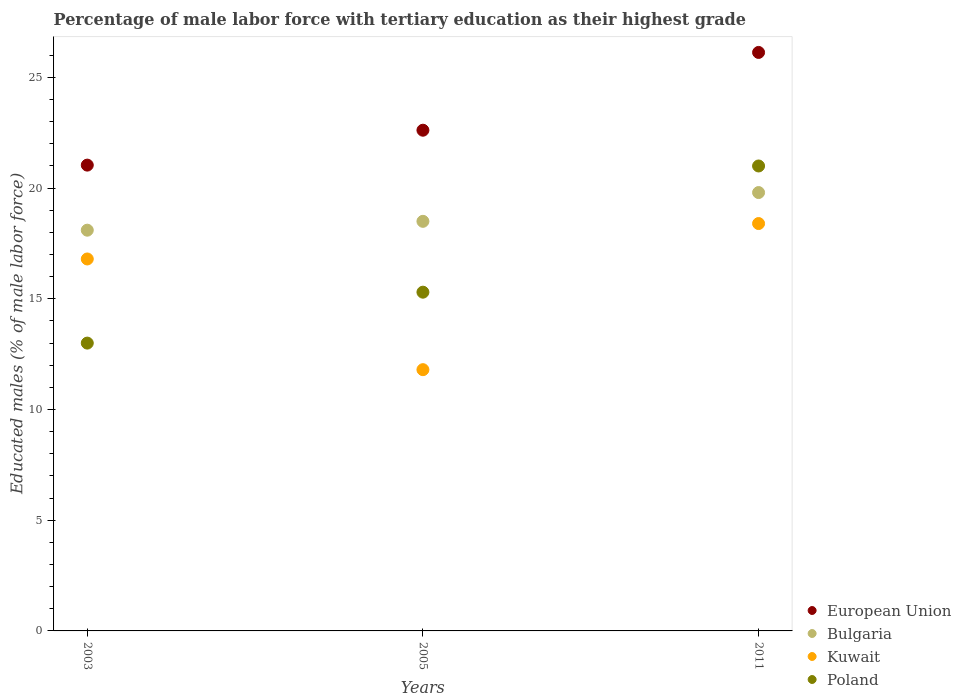Is the number of dotlines equal to the number of legend labels?
Provide a short and direct response. Yes. What is the percentage of male labor force with tertiary education in Poland in 2011?
Offer a very short reply. 21. Across all years, what is the maximum percentage of male labor force with tertiary education in Kuwait?
Offer a very short reply. 18.4. Across all years, what is the minimum percentage of male labor force with tertiary education in Bulgaria?
Your answer should be very brief. 18.1. What is the total percentage of male labor force with tertiary education in European Union in the graph?
Offer a very short reply. 69.78. What is the difference between the percentage of male labor force with tertiary education in Kuwait in 2003 and that in 2005?
Provide a short and direct response. 5. What is the difference between the percentage of male labor force with tertiary education in European Union in 2003 and the percentage of male labor force with tertiary education in Bulgaria in 2005?
Your answer should be very brief. 2.54. What is the average percentage of male labor force with tertiary education in European Union per year?
Give a very brief answer. 23.26. In the year 2003, what is the difference between the percentage of male labor force with tertiary education in European Union and percentage of male labor force with tertiary education in Poland?
Offer a very short reply. 8.04. In how many years, is the percentage of male labor force with tertiary education in European Union greater than 21 %?
Keep it short and to the point. 3. What is the ratio of the percentage of male labor force with tertiary education in Poland in 2003 to that in 2005?
Keep it short and to the point. 0.85. What is the difference between the highest and the second highest percentage of male labor force with tertiary education in European Union?
Make the answer very short. 3.51. What is the difference between the highest and the lowest percentage of male labor force with tertiary education in Bulgaria?
Your response must be concise. 1.7. Is it the case that in every year, the sum of the percentage of male labor force with tertiary education in Bulgaria and percentage of male labor force with tertiary education in Poland  is greater than the sum of percentage of male labor force with tertiary education in Kuwait and percentage of male labor force with tertiary education in European Union?
Make the answer very short. No. Is it the case that in every year, the sum of the percentage of male labor force with tertiary education in European Union and percentage of male labor force with tertiary education in Poland  is greater than the percentage of male labor force with tertiary education in Bulgaria?
Offer a terse response. Yes. Is the percentage of male labor force with tertiary education in Poland strictly greater than the percentage of male labor force with tertiary education in European Union over the years?
Provide a succinct answer. No. Is the percentage of male labor force with tertiary education in Kuwait strictly less than the percentage of male labor force with tertiary education in Poland over the years?
Make the answer very short. No. How many dotlines are there?
Your answer should be compact. 4. How many years are there in the graph?
Keep it short and to the point. 3. Does the graph contain any zero values?
Ensure brevity in your answer.  No. Does the graph contain grids?
Ensure brevity in your answer.  No. Where does the legend appear in the graph?
Ensure brevity in your answer.  Bottom right. How many legend labels are there?
Your answer should be compact. 4. How are the legend labels stacked?
Provide a succinct answer. Vertical. What is the title of the graph?
Your answer should be very brief. Percentage of male labor force with tertiary education as their highest grade. Does "Dominican Republic" appear as one of the legend labels in the graph?
Your answer should be compact. No. What is the label or title of the Y-axis?
Provide a short and direct response. Educated males (% of male labor force). What is the Educated males (% of male labor force) in European Union in 2003?
Provide a short and direct response. 21.04. What is the Educated males (% of male labor force) in Bulgaria in 2003?
Your answer should be compact. 18.1. What is the Educated males (% of male labor force) in Kuwait in 2003?
Your response must be concise. 16.8. What is the Educated males (% of male labor force) of European Union in 2005?
Provide a short and direct response. 22.62. What is the Educated males (% of male labor force) in Bulgaria in 2005?
Your answer should be compact. 18.5. What is the Educated males (% of male labor force) in Kuwait in 2005?
Ensure brevity in your answer.  11.8. What is the Educated males (% of male labor force) in Poland in 2005?
Your response must be concise. 15.3. What is the Educated males (% of male labor force) in European Union in 2011?
Ensure brevity in your answer.  26.13. What is the Educated males (% of male labor force) of Bulgaria in 2011?
Provide a succinct answer. 19.8. What is the Educated males (% of male labor force) in Kuwait in 2011?
Keep it short and to the point. 18.4. Across all years, what is the maximum Educated males (% of male labor force) of European Union?
Give a very brief answer. 26.13. Across all years, what is the maximum Educated males (% of male labor force) in Bulgaria?
Ensure brevity in your answer.  19.8. Across all years, what is the maximum Educated males (% of male labor force) in Kuwait?
Give a very brief answer. 18.4. Across all years, what is the minimum Educated males (% of male labor force) in European Union?
Keep it short and to the point. 21.04. Across all years, what is the minimum Educated males (% of male labor force) in Bulgaria?
Give a very brief answer. 18.1. Across all years, what is the minimum Educated males (% of male labor force) in Kuwait?
Keep it short and to the point. 11.8. Across all years, what is the minimum Educated males (% of male labor force) of Poland?
Provide a short and direct response. 13. What is the total Educated males (% of male labor force) in European Union in the graph?
Offer a very short reply. 69.78. What is the total Educated males (% of male labor force) in Bulgaria in the graph?
Keep it short and to the point. 56.4. What is the total Educated males (% of male labor force) of Poland in the graph?
Ensure brevity in your answer.  49.3. What is the difference between the Educated males (% of male labor force) of European Union in 2003 and that in 2005?
Provide a succinct answer. -1.58. What is the difference between the Educated males (% of male labor force) of Bulgaria in 2003 and that in 2005?
Your answer should be very brief. -0.4. What is the difference between the Educated males (% of male labor force) in Kuwait in 2003 and that in 2005?
Your answer should be very brief. 5. What is the difference between the Educated males (% of male labor force) in Poland in 2003 and that in 2005?
Ensure brevity in your answer.  -2.3. What is the difference between the Educated males (% of male labor force) of European Union in 2003 and that in 2011?
Offer a very short reply. -5.09. What is the difference between the Educated males (% of male labor force) in Bulgaria in 2003 and that in 2011?
Keep it short and to the point. -1.7. What is the difference between the Educated males (% of male labor force) in Kuwait in 2003 and that in 2011?
Your answer should be compact. -1.6. What is the difference between the Educated males (% of male labor force) in European Union in 2005 and that in 2011?
Your answer should be compact. -3.51. What is the difference between the Educated males (% of male labor force) of Poland in 2005 and that in 2011?
Offer a terse response. -5.7. What is the difference between the Educated males (% of male labor force) of European Union in 2003 and the Educated males (% of male labor force) of Bulgaria in 2005?
Offer a terse response. 2.54. What is the difference between the Educated males (% of male labor force) in European Union in 2003 and the Educated males (% of male labor force) in Kuwait in 2005?
Your answer should be very brief. 9.24. What is the difference between the Educated males (% of male labor force) of European Union in 2003 and the Educated males (% of male labor force) of Poland in 2005?
Give a very brief answer. 5.74. What is the difference between the Educated males (% of male labor force) of Bulgaria in 2003 and the Educated males (% of male labor force) of Poland in 2005?
Give a very brief answer. 2.8. What is the difference between the Educated males (% of male labor force) in Kuwait in 2003 and the Educated males (% of male labor force) in Poland in 2005?
Your answer should be compact. 1.5. What is the difference between the Educated males (% of male labor force) of European Union in 2003 and the Educated males (% of male labor force) of Bulgaria in 2011?
Keep it short and to the point. 1.24. What is the difference between the Educated males (% of male labor force) of European Union in 2003 and the Educated males (% of male labor force) of Kuwait in 2011?
Give a very brief answer. 2.64. What is the difference between the Educated males (% of male labor force) in European Union in 2003 and the Educated males (% of male labor force) in Poland in 2011?
Make the answer very short. 0.04. What is the difference between the Educated males (% of male labor force) of Bulgaria in 2003 and the Educated males (% of male labor force) of Kuwait in 2011?
Keep it short and to the point. -0.3. What is the difference between the Educated males (% of male labor force) of Bulgaria in 2003 and the Educated males (% of male labor force) of Poland in 2011?
Offer a very short reply. -2.9. What is the difference between the Educated males (% of male labor force) of Kuwait in 2003 and the Educated males (% of male labor force) of Poland in 2011?
Provide a short and direct response. -4.2. What is the difference between the Educated males (% of male labor force) in European Union in 2005 and the Educated males (% of male labor force) in Bulgaria in 2011?
Make the answer very short. 2.82. What is the difference between the Educated males (% of male labor force) of European Union in 2005 and the Educated males (% of male labor force) of Kuwait in 2011?
Ensure brevity in your answer.  4.22. What is the difference between the Educated males (% of male labor force) of European Union in 2005 and the Educated males (% of male labor force) of Poland in 2011?
Provide a short and direct response. 1.62. What is the difference between the Educated males (% of male labor force) of Bulgaria in 2005 and the Educated males (% of male labor force) of Kuwait in 2011?
Keep it short and to the point. 0.1. What is the difference between the Educated males (% of male labor force) in Kuwait in 2005 and the Educated males (% of male labor force) in Poland in 2011?
Your response must be concise. -9.2. What is the average Educated males (% of male labor force) in European Union per year?
Give a very brief answer. 23.26. What is the average Educated males (% of male labor force) in Bulgaria per year?
Offer a very short reply. 18.8. What is the average Educated males (% of male labor force) in Kuwait per year?
Provide a succinct answer. 15.67. What is the average Educated males (% of male labor force) of Poland per year?
Keep it short and to the point. 16.43. In the year 2003, what is the difference between the Educated males (% of male labor force) in European Union and Educated males (% of male labor force) in Bulgaria?
Keep it short and to the point. 2.94. In the year 2003, what is the difference between the Educated males (% of male labor force) of European Union and Educated males (% of male labor force) of Kuwait?
Offer a very short reply. 4.24. In the year 2003, what is the difference between the Educated males (% of male labor force) of European Union and Educated males (% of male labor force) of Poland?
Your answer should be compact. 8.04. In the year 2005, what is the difference between the Educated males (% of male labor force) in European Union and Educated males (% of male labor force) in Bulgaria?
Your answer should be compact. 4.12. In the year 2005, what is the difference between the Educated males (% of male labor force) of European Union and Educated males (% of male labor force) of Kuwait?
Keep it short and to the point. 10.82. In the year 2005, what is the difference between the Educated males (% of male labor force) of European Union and Educated males (% of male labor force) of Poland?
Ensure brevity in your answer.  7.32. In the year 2005, what is the difference between the Educated males (% of male labor force) of Bulgaria and Educated males (% of male labor force) of Kuwait?
Provide a short and direct response. 6.7. In the year 2005, what is the difference between the Educated males (% of male labor force) in Bulgaria and Educated males (% of male labor force) in Poland?
Keep it short and to the point. 3.2. In the year 2005, what is the difference between the Educated males (% of male labor force) in Kuwait and Educated males (% of male labor force) in Poland?
Provide a succinct answer. -3.5. In the year 2011, what is the difference between the Educated males (% of male labor force) of European Union and Educated males (% of male labor force) of Bulgaria?
Provide a succinct answer. 6.33. In the year 2011, what is the difference between the Educated males (% of male labor force) in European Union and Educated males (% of male labor force) in Kuwait?
Ensure brevity in your answer.  7.73. In the year 2011, what is the difference between the Educated males (% of male labor force) of European Union and Educated males (% of male labor force) of Poland?
Your answer should be compact. 5.13. In the year 2011, what is the difference between the Educated males (% of male labor force) of Bulgaria and Educated males (% of male labor force) of Kuwait?
Make the answer very short. 1.4. In the year 2011, what is the difference between the Educated males (% of male labor force) in Bulgaria and Educated males (% of male labor force) in Poland?
Provide a short and direct response. -1.2. What is the ratio of the Educated males (% of male labor force) in European Union in 2003 to that in 2005?
Make the answer very short. 0.93. What is the ratio of the Educated males (% of male labor force) in Bulgaria in 2003 to that in 2005?
Your answer should be very brief. 0.98. What is the ratio of the Educated males (% of male labor force) in Kuwait in 2003 to that in 2005?
Ensure brevity in your answer.  1.42. What is the ratio of the Educated males (% of male labor force) of Poland in 2003 to that in 2005?
Provide a succinct answer. 0.85. What is the ratio of the Educated males (% of male labor force) of European Union in 2003 to that in 2011?
Provide a short and direct response. 0.81. What is the ratio of the Educated males (% of male labor force) in Bulgaria in 2003 to that in 2011?
Your answer should be compact. 0.91. What is the ratio of the Educated males (% of male labor force) of Kuwait in 2003 to that in 2011?
Your response must be concise. 0.91. What is the ratio of the Educated males (% of male labor force) of Poland in 2003 to that in 2011?
Provide a succinct answer. 0.62. What is the ratio of the Educated males (% of male labor force) in European Union in 2005 to that in 2011?
Provide a succinct answer. 0.87. What is the ratio of the Educated males (% of male labor force) in Bulgaria in 2005 to that in 2011?
Your answer should be very brief. 0.93. What is the ratio of the Educated males (% of male labor force) in Kuwait in 2005 to that in 2011?
Your answer should be compact. 0.64. What is the ratio of the Educated males (% of male labor force) in Poland in 2005 to that in 2011?
Offer a terse response. 0.73. What is the difference between the highest and the second highest Educated males (% of male labor force) of European Union?
Make the answer very short. 3.51. What is the difference between the highest and the second highest Educated males (% of male labor force) of Bulgaria?
Your response must be concise. 1.3. What is the difference between the highest and the second highest Educated males (% of male labor force) of Kuwait?
Make the answer very short. 1.6. What is the difference between the highest and the second highest Educated males (% of male labor force) in Poland?
Your answer should be very brief. 5.7. What is the difference between the highest and the lowest Educated males (% of male labor force) in European Union?
Provide a short and direct response. 5.09. What is the difference between the highest and the lowest Educated males (% of male labor force) in Bulgaria?
Offer a very short reply. 1.7. What is the difference between the highest and the lowest Educated males (% of male labor force) in Poland?
Your answer should be compact. 8. 